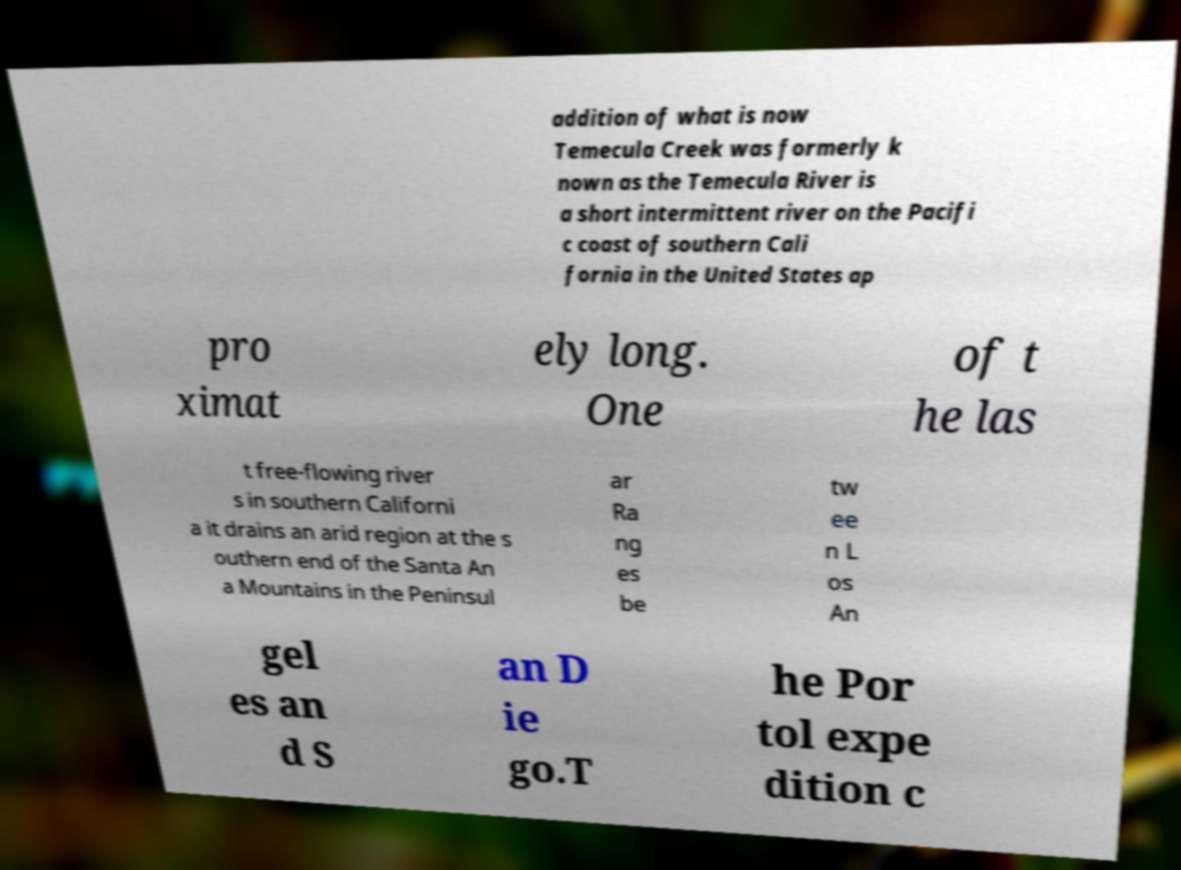For documentation purposes, I need the text within this image transcribed. Could you provide that? addition of what is now Temecula Creek was formerly k nown as the Temecula River is a short intermittent river on the Pacifi c coast of southern Cali fornia in the United States ap pro ximat ely long. One of t he las t free-flowing river s in southern Californi a it drains an arid region at the s outhern end of the Santa An a Mountains in the Peninsul ar Ra ng es be tw ee n L os An gel es an d S an D ie go.T he Por tol expe dition c 